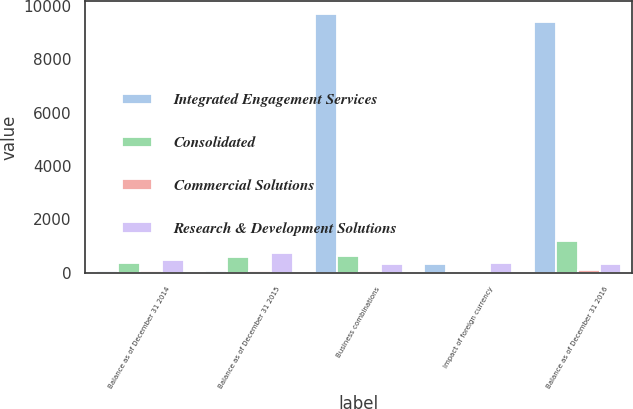Convert chart. <chart><loc_0><loc_0><loc_500><loc_500><stacked_bar_chart><ecel><fcel>Balance as of December 31 2014<fcel>Balance as of December 31 2015<fcel>Business combinations<fcel>Impact of foreign currency<fcel>Balance as of December 31 2016<nl><fcel>Integrated Engagement Services<fcel>70<fcel>70<fcel>9698<fcel>330<fcel>9415<nl><fcel>Consolidated<fcel>346<fcel>602<fcel>611<fcel>17<fcel>1196<nl><fcel>Commercial Solutions<fcel>48<fcel>48<fcel>67<fcel>1<fcel>116<nl><fcel>Research & Development Solutions<fcel>464<fcel>720<fcel>338<fcel>346<fcel>338<nl></chart> 